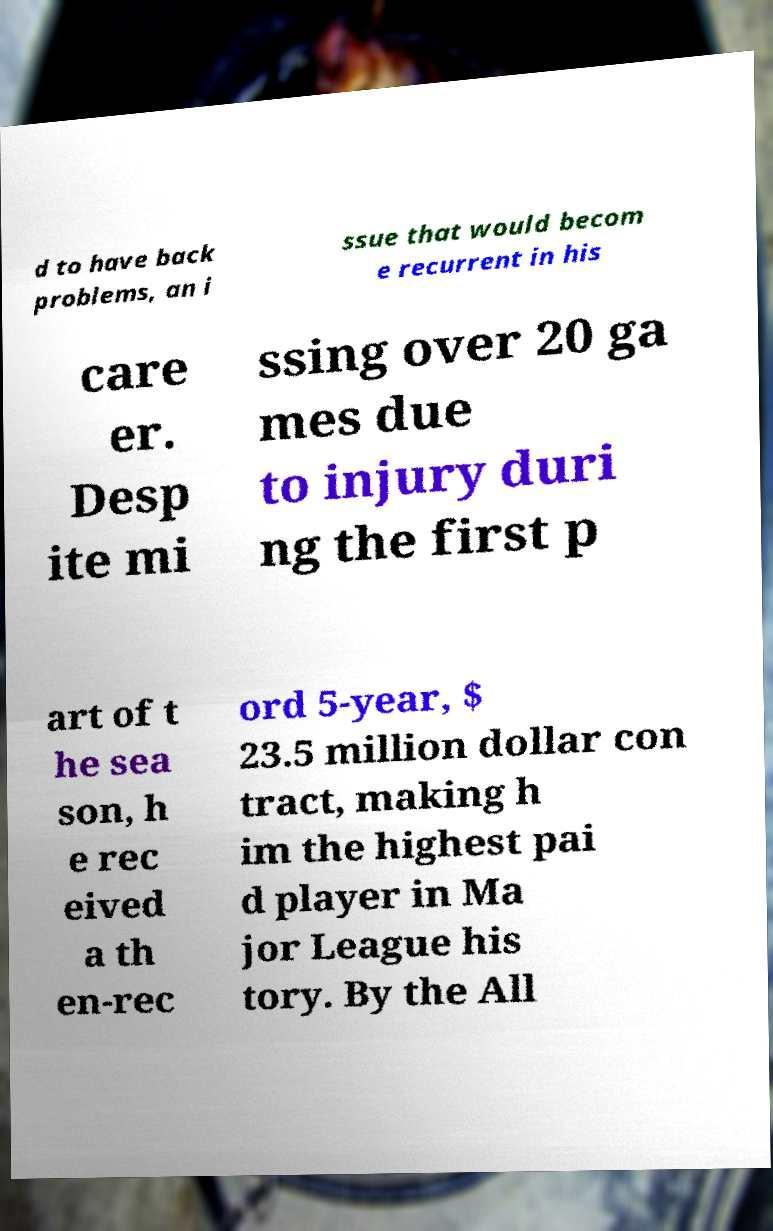Can you accurately transcribe the text from the provided image for me? d to have back problems, an i ssue that would becom e recurrent in his care er. Desp ite mi ssing over 20 ga mes due to injury duri ng the first p art of t he sea son, h e rec eived a th en-rec ord 5-year, $ 23.5 million dollar con tract, making h im the highest pai d player in Ma jor League his tory. By the All 